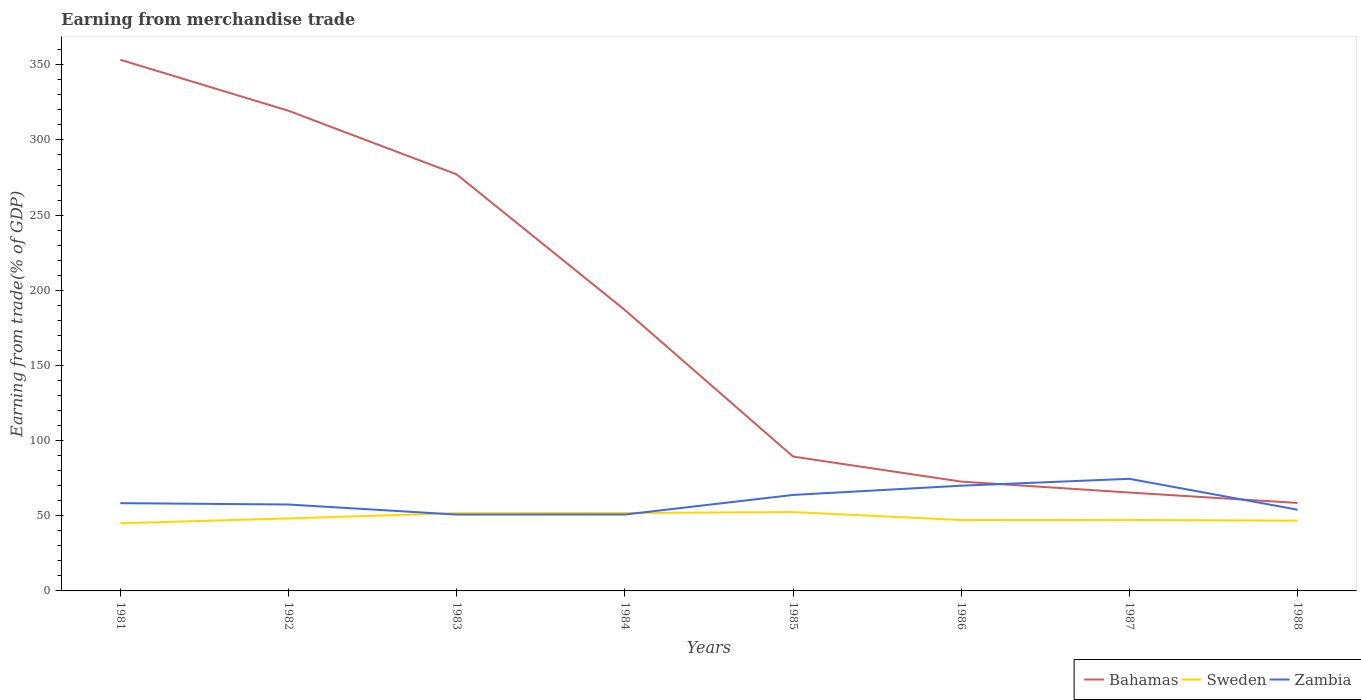Does the line corresponding to Zambia intersect with the line corresponding to Sweden?
Your answer should be very brief. Yes. Is the number of lines equal to the number of legend labels?
Make the answer very short. Yes. Across all years, what is the maximum earnings from trade in Zambia?
Provide a succinct answer. 50.8. In which year was the earnings from trade in Zambia maximum?
Provide a short and direct response. 1983. What is the total earnings from trade in Bahamas in the graph?
Provide a short and direct response. 253.96. What is the difference between the highest and the second highest earnings from trade in Sweden?
Keep it short and to the point. 7.48. How many lines are there?
Keep it short and to the point. 3. What is the difference between two consecutive major ticks on the Y-axis?
Make the answer very short. 50. Does the graph contain any zero values?
Offer a very short reply. No. What is the title of the graph?
Your answer should be very brief. Earning from merchandise trade. What is the label or title of the X-axis?
Provide a succinct answer. Years. What is the label or title of the Y-axis?
Your answer should be very brief. Earning from trade(% of GDP). What is the Earning from trade(% of GDP) of Bahamas in 1981?
Offer a very short reply. 353.31. What is the Earning from trade(% of GDP) of Sweden in 1981?
Offer a terse response. 44.97. What is the Earning from trade(% of GDP) in Zambia in 1981?
Offer a very short reply. 58.38. What is the Earning from trade(% of GDP) of Bahamas in 1982?
Offer a very short reply. 319.39. What is the Earning from trade(% of GDP) in Sweden in 1982?
Your answer should be compact. 48.23. What is the Earning from trade(% of GDP) in Zambia in 1982?
Make the answer very short. 57.48. What is the Earning from trade(% of GDP) of Bahamas in 1983?
Give a very brief answer. 277.07. What is the Earning from trade(% of GDP) of Sweden in 1983?
Offer a terse response. 51.72. What is the Earning from trade(% of GDP) in Zambia in 1983?
Provide a succinct answer. 50.8. What is the Earning from trade(% of GDP) of Bahamas in 1984?
Ensure brevity in your answer.  186.86. What is the Earning from trade(% of GDP) of Sweden in 1984?
Your answer should be compact. 51.83. What is the Earning from trade(% of GDP) in Zambia in 1984?
Offer a terse response. 50.82. What is the Earning from trade(% of GDP) of Bahamas in 1985?
Your answer should be very brief. 89.37. What is the Earning from trade(% of GDP) of Sweden in 1985?
Your response must be concise. 52.45. What is the Earning from trade(% of GDP) of Zambia in 1985?
Provide a short and direct response. 63.84. What is the Earning from trade(% of GDP) in Bahamas in 1986?
Your answer should be very brief. 72.72. What is the Earning from trade(% of GDP) of Sweden in 1986?
Offer a very short reply. 47.15. What is the Earning from trade(% of GDP) of Zambia in 1986?
Your answer should be compact. 69.99. What is the Earning from trade(% of GDP) in Bahamas in 1987?
Keep it short and to the point. 65.44. What is the Earning from trade(% of GDP) in Sweden in 1987?
Provide a short and direct response. 47.23. What is the Earning from trade(% of GDP) of Zambia in 1987?
Offer a very short reply. 74.56. What is the Earning from trade(% of GDP) of Bahamas in 1988?
Provide a short and direct response. 58.52. What is the Earning from trade(% of GDP) of Sweden in 1988?
Make the answer very short. 46.74. What is the Earning from trade(% of GDP) of Zambia in 1988?
Your answer should be very brief. 54.01. Across all years, what is the maximum Earning from trade(% of GDP) of Bahamas?
Your answer should be compact. 353.31. Across all years, what is the maximum Earning from trade(% of GDP) of Sweden?
Your answer should be very brief. 52.45. Across all years, what is the maximum Earning from trade(% of GDP) in Zambia?
Provide a succinct answer. 74.56. Across all years, what is the minimum Earning from trade(% of GDP) in Bahamas?
Make the answer very short. 58.52. Across all years, what is the minimum Earning from trade(% of GDP) in Sweden?
Provide a succinct answer. 44.97. Across all years, what is the minimum Earning from trade(% of GDP) of Zambia?
Provide a short and direct response. 50.8. What is the total Earning from trade(% of GDP) of Bahamas in the graph?
Offer a very short reply. 1422.68. What is the total Earning from trade(% of GDP) of Sweden in the graph?
Provide a succinct answer. 390.31. What is the total Earning from trade(% of GDP) of Zambia in the graph?
Provide a succinct answer. 479.88. What is the difference between the Earning from trade(% of GDP) of Bahamas in 1981 and that in 1982?
Provide a succinct answer. 33.92. What is the difference between the Earning from trade(% of GDP) of Sweden in 1981 and that in 1982?
Provide a short and direct response. -3.26. What is the difference between the Earning from trade(% of GDP) in Zambia in 1981 and that in 1982?
Your answer should be compact. 0.9. What is the difference between the Earning from trade(% of GDP) of Bahamas in 1981 and that in 1983?
Provide a succinct answer. 76.25. What is the difference between the Earning from trade(% of GDP) in Sweden in 1981 and that in 1983?
Offer a very short reply. -6.75. What is the difference between the Earning from trade(% of GDP) in Zambia in 1981 and that in 1983?
Your answer should be very brief. 7.58. What is the difference between the Earning from trade(% of GDP) in Bahamas in 1981 and that in 1984?
Offer a terse response. 166.45. What is the difference between the Earning from trade(% of GDP) in Sweden in 1981 and that in 1984?
Make the answer very short. -6.86. What is the difference between the Earning from trade(% of GDP) in Zambia in 1981 and that in 1984?
Ensure brevity in your answer.  7.56. What is the difference between the Earning from trade(% of GDP) in Bahamas in 1981 and that in 1985?
Ensure brevity in your answer.  263.94. What is the difference between the Earning from trade(% of GDP) in Sweden in 1981 and that in 1985?
Your response must be concise. -7.48. What is the difference between the Earning from trade(% of GDP) in Zambia in 1981 and that in 1985?
Ensure brevity in your answer.  -5.46. What is the difference between the Earning from trade(% of GDP) of Bahamas in 1981 and that in 1986?
Give a very brief answer. 280.59. What is the difference between the Earning from trade(% of GDP) of Sweden in 1981 and that in 1986?
Keep it short and to the point. -2.18. What is the difference between the Earning from trade(% of GDP) in Zambia in 1981 and that in 1986?
Offer a very short reply. -11.61. What is the difference between the Earning from trade(% of GDP) in Bahamas in 1981 and that in 1987?
Offer a very short reply. 287.87. What is the difference between the Earning from trade(% of GDP) in Sweden in 1981 and that in 1987?
Provide a short and direct response. -2.26. What is the difference between the Earning from trade(% of GDP) in Zambia in 1981 and that in 1987?
Make the answer very short. -16.18. What is the difference between the Earning from trade(% of GDP) in Bahamas in 1981 and that in 1988?
Keep it short and to the point. 294.79. What is the difference between the Earning from trade(% of GDP) in Sweden in 1981 and that in 1988?
Make the answer very short. -1.77. What is the difference between the Earning from trade(% of GDP) in Zambia in 1981 and that in 1988?
Your answer should be very brief. 4.37. What is the difference between the Earning from trade(% of GDP) of Bahamas in 1982 and that in 1983?
Ensure brevity in your answer.  42.33. What is the difference between the Earning from trade(% of GDP) of Sweden in 1982 and that in 1983?
Provide a succinct answer. -3.48. What is the difference between the Earning from trade(% of GDP) in Zambia in 1982 and that in 1983?
Your answer should be very brief. 6.68. What is the difference between the Earning from trade(% of GDP) in Bahamas in 1982 and that in 1984?
Offer a very short reply. 132.53. What is the difference between the Earning from trade(% of GDP) of Sweden in 1982 and that in 1984?
Make the answer very short. -3.6. What is the difference between the Earning from trade(% of GDP) in Zambia in 1982 and that in 1984?
Your answer should be very brief. 6.66. What is the difference between the Earning from trade(% of GDP) in Bahamas in 1982 and that in 1985?
Your answer should be compact. 230.02. What is the difference between the Earning from trade(% of GDP) of Sweden in 1982 and that in 1985?
Ensure brevity in your answer.  -4.21. What is the difference between the Earning from trade(% of GDP) of Zambia in 1982 and that in 1985?
Your answer should be compact. -6.36. What is the difference between the Earning from trade(% of GDP) in Bahamas in 1982 and that in 1986?
Give a very brief answer. 246.67. What is the difference between the Earning from trade(% of GDP) of Sweden in 1982 and that in 1986?
Your response must be concise. 1.09. What is the difference between the Earning from trade(% of GDP) of Zambia in 1982 and that in 1986?
Keep it short and to the point. -12.52. What is the difference between the Earning from trade(% of GDP) in Bahamas in 1982 and that in 1987?
Offer a very short reply. 253.96. What is the difference between the Earning from trade(% of GDP) in Sweden in 1982 and that in 1987?
Make the answer very short. 1.01. What is the difference between the Earning from trade(% of GDP) in Zambia in 1982 and that in 1987?
Give a very brief answer. -17.08. What is the difference between the Earning from trade(% of GDP) in Bahamas in 1982 and that in 1988?
Offer a terse response. 260.88. What is the difference between the Earning from trade(% of GDP) of Sweden in 1982 and that in 1988?
Your answer should be compact. 1.5. What is the difference between the Earning from trade(% of GDP) of Zambia in 1982 and that in 1988?
Offer a terse response. 3.47. What is the difference between the Earning from trade(% of GDP) in Bahamas in 1983 and that in 1984?
Your response must be concise. 90.21. What is the difference between the Earning from trade(% of GDP) of Sweden in 1983 and that in 1984?
Keep it short and to the point. -0.12. What is the difference between the Earning from trade(% of GDP) of Zambia in 1983 and that in 1984?
Give a very brief answer. -0.02. What is the difference between the Earning from trade(% of GDP) of Bahamas in 1983 and that in 1985?
Keep it short and to the point. 187.7. What is the difference between the Earning from trade(% of GDP) in Sweden in 1983 and that in 1985?
Keep it short and to the point. -0.73. What is the difference between the Earning from trade(% of GDP) of Zambia in 1983 and that in 1985?
Offer a very short reply. -13.04. What is the difference between the Earning from trade(% of GDP) of Bahamas in 1983 and that in 1986?
Ensure brevity in your answer.  204.35. What is the difference between the Earning from trade(% of GDP) of Sweden in 1983 and that in 1986?
Ensure brevity in your answer.  4.57. What is the difference between the Earning from trade(% of GDP) in Zambia in 1983 and that in 1986?
Make the answer very short. -19.2. What is the difference between the Earning from trade(% of GDP) in Bahamas in 1983 and that in 1987?
Offer a terse response. 211.63. What is the difference between the Earning from trade(% of GDP) in Sweden in 1983 and that in 1987?
Your response must be concise. 4.49. What is the difference between the Earning from trade(% of GDP) of Zambia in 1983 and that in 1987?
Make the answer very short. -23.76. What is the difference between the Earning from trade(% of GDP) in Bahamas in 1983 and that in 1988?
Your answer should be very brief. 218.55. What is the difference between the Earning from trade(% of GDP) in Sweden in 1983 and that in 1988?
Offer a terse response. 4.98. What is the difference between the Earning from trade(% of GDP) of Zambia in 1983 and that in 1988?
Provide a short and direct response. -3.21. What is the difference between the Earning from trade(% of GDP) of Bahamas in 1984 and that in 1985?
Your response must be concise. 97.49. What is the difference between the Earning from trade(% of GDP) in Sweden in 1984 and that in 1985?
Your response must be concise. -0.61. What is the difference between the Earning from trade(% of GDP) in Zambia in 1984 and that in 1985?
Keep it short and to the point. -13.02. What is the difference between the Earning from trade(% of GDP) of Bahamas in 1984 and that in 1986?
Ensure brevity in your answer.  114.14. What is the difference between the Earning from trade(% of GDP) in Sweden in 1984 and that in 1986?
Keep it short and to the point. 4.68. What is the difference between the Earning from trade(% of GDP) in Zambia in 1984 and that in 1986?
Offer a very short reply. -19.18. What is the difference between the Earning from trade(% of GDP) in Bahamas in 1984 and that in 1987?
Your answer should be very brief. 121.42. What is the difference between the Earning from trade(% of GDP) of Sweden in 1984 and that in 1987?
Make the answer very short. 4.61. What is the difference between the Earning from trade(% of GDP) in Zambia in 1984 and that in 1987?
Your answer should be very brief. -23.74. What is the difference between the Earning from trade(% of GDP) of Bahamas in 1984 and that in 1988?
Offer a very short reply. 128.34. What is the difference between the Earning from trade(% of GDP) of Sweden in 1984 and that in 1988?
Keep it short and to the point. 5.1. What is the difference between the Earning from trade(% of GDP) in Zambia in 1984 and that in 1988?
Keep it short and to the point. -3.19. What is the difference between the Earning from trade(% of GDP) of Bahamas in 1985 and that in 1986?
Your answer should be very brief. 16.65. What is the difference between the Earning from trade(% of GDP) in Sweden in 1985 and that in 1986?
Ensure brevity in your answer.  5.3. What is the difference between the Earning from trade(% of GDP) in Zambia in 1985 and that in 1986?
Give a very brief answer. -6.15. What is the difference between the Earning from trade(% of GDP) in Bahamas in 1985 and that in 1987?
Your answer should be very brief. 23.93. What is the difference between the Earning from trade(% of GDP) in Sweden in 1985 and that in 1987?
Provide a succinct answer. 5.22. What is the difference between the Earning from trade(% of GDP) of Zambia in 1985 and that in 1987?
Make the answer very short. -10.72. What is the difference between the Earning from trade(% of GDP) of Bahamas in 1985 and that in 1988?
Offer a very short reply. 30.85. What is the difference between the Earning from trade(% of GDP) of Sweden in 1985 and that in 1988?
Make the answer very short. 5.71. What is the difference between the Earning from trade(% of GDP) of Zambia in 1985 and that in 1988?
Offer a terse response. 9.83. What is the difference between the Earning from trade(% of GDP) in Bahamas in 1986 and that in 1987?
Your answer should be compact. 7.28. What is the difference between the Earning from trade(% of GDP) in Sweden in 1986 and that in 1987?
Your answer should be compact. -0.08. What is the difference between the Earning from trade(% of GDP) of Zambia in 1986 and that in 1987?
Give a very brief answer. -4.57. What is the difference between the Earning from trade(% of GDP) of Bahamas in 1986 and that in 1988?
Make the answer very short. 14.2. What is the difference between the Earning from trade(% of GDP) of Sweden in 1986 and that in 1988?
Make the answer very short. 0.41. What is the difference between the Earning from trade(% of GDP) of Zambia in 1986 and that in 1988?
Your answer should be compact. 15.98. What is the difference between the Earning from trade(% of GDP) of Bahamas in 1987 and that in 1988?
Make the answer very short. 6.92. What is the difference between the Earning from trade(% of GDP) of Sweden in 1987 and that in 1988?
Offer a terse response. 0.49. What is the difference between the Earning from trade(% of GDP) in Zambia in 1987 and that in 1988?
Keep it short and to the point. 20.55. What is the difference between the Earning from trade(% of GDP) in Bahamas in 1981 and the Earning from trade(% of GDP) in Sweden in 1982?
Give a very brief answer. 305.08. What is the difference between the Earning from trade(% of GDP) of Bahamas in 1981 and the Earning from trade(% of GDP) of Zambia in 1982?
Give a very brief answer. 295.84. What is the difference between the Earning from trade(% of GDP) in Sweden in 1981 and the Earning from trade(% of GDP) in Zambia in 1982?
Your response must be concise. -12.51. What is the difference between the Earning from trade(% of GDP) in Bahamas in 1981 and the Earning from trade(% of GDP) in Sweden in 1983?
Offer a very short reply. 301.6. What is the difference between the Earning from trade(% of GDP) in Bahamas in 1981 and the Earning from trade(% of GDP) in Zambia in 1983?
Keep it short and to the point. 302.52. What is the difference between the Earning from trade(% of GDP) of Sweden in 1981 and the Earning from trade(% of GDP) of Zambia in 1983?
Make the answer very short. -5.83. What is the difference between the Earning from trade(% of GDP) of Bahamas in 1981 and the Earning from trade(% of GDP) of Sweden in 1984?
Provide a short and direct response. 301.48. What is the difference between the Earning from trade(% of GDP) of Bahamas in 1981 and the Earning from trade(% of GDP) of Zambia in 1984?
Make the answer very short. 302.49. What is the difference between the Earning from trade(% of GDP) of Sweden in 1981 and the Earning from trade(% of GDP) of Zambia in 1984?
Provide a short and direct response. -5.85. What is the difference between the Earning from trade(% of GDP) in Bahamas in 1981 and the Earning from trade(% of GDP) in Sweden in 1985?
Offer a very short reply. 300.87. What is the difference between the Earning from trade(% of GDP) in Bahamas in 1981 and the Earning from trade(% of GDP) in Zambia in 1985?
Keep it short and to the point. 289.47. What is the difference between the Earning from trade(% of GDP) of Sweden in 1981 and the Earning from trade(% of GDP) of Zambia in 1985?
Ensure brevity in your answer.  -18.87. What is the difference between the Earning from trade(% of GDP) in Bahamas in 1981 and the Earning from trade(% of GDP) in Sweden in 1986?
Your answer should be compact. 306.16. What is the difference between the Earning from trade(% of GDP) in Bahamas in 1981 and the Earning from trade(% of GDP) in Zambia in 1986?
Make the answer very short. 283.32. What is the difference between the Earning from trade(% of GDP) in Sweden in 1981 and the Earning from trade(% of GDP) in Zambia in 1986?
Make the answer very short. -25.02. What is the difference between the Earning from trade(% of GDP) of Bahamas in 1981 and the Earning from trade(% of GDP) of Sweden in 1987?
Offer a terse response. 306.08. What is the difference between the Earning from trade(% of GDP) in Bahamas in 1981 and the Earning from trade(% of GDP) in Zambia in 1987?
Ensure brevity in your answer.  278.75. What is the difference between the Earning from trade(% of GDP) in Sweden in 1981 and the Earning from trade(% of GDP) in Zambia in 1987?
Your answer should be compact. -29.59. What is the difference between the Earning from trade(% of GDP) of Bahamas in 1981 and the Earning from trade(% of GDP) of Sweden in 1988?
Offer a very short reply. 306.58. What is the difference between the Earning from trade(% of GDP) in Bahamas in 1981 and the Earning from trade(% of GDP) in Zambia in 1988?
Keep it short and to the point. 299.3. What is the difference between the Earning from trade(% of GDP) of Sweden in 1981 and the Earning from trade(% of GDP) of Zambia in 1988?
Ensure brevity in your answer.  -9.04. What is the difference between the Earning from trade(% of GDP) in Bahamas in 1982 and the Earning from trade(% of GDP) in Sweden in 1983?
Ensure brevity in your answer.  267.68. What is the difference between the Earning from trade(% of GDP) in Bahamas in 1982 and the Earning from trade(% of GDP) in Zambia in 1983?
Provide a short and direct response. 268.6. What is the difference between the Earning from trade(% of GDP) in Sweden in 1982 and the Earning from trade(% of GDP) in Zambia in 1983?
Give a very brief answer. -2.56. What is the difference between the Earning from trade(% of GDP) of Bahamas in 1982 and the Earning from trade(% of GDP) of Sweden in 1984?
Offer a very short reply. 267.56. What is the difference between the Earning from trade(% of GDP) of Bahamas in 1982 and the Earning from trade(% of GDP) of Zambia in 1984?
Make the answer very short. 268.58. What is the difference between the Earning from trade(% of GDP) of Sweden in 1982 and the Earning from trade(% of GDP) of Zambia in 1984?
Your response must be concise. -2.58. What is the difference between the Earning from trade(% of GDP) of Bahamas in 1982 and the Earning from trade(% of GDP) of Sweden in 1985?
Offer a very short reply. 266.95. What is the difference between the Earning from trade(% of GDP) in Bahamas in 1982 and the Earning from trade(% of GDP) in Zambia in 1985?
Make the answer very short. 255.55. What is the difference between the Earning from trade(% of GDP) in Sweden in 1982 and the Earning from trade(% of GDP) in Zambia in 1985?
Offer a very short reply. -15.61. What is the difference between the Earning from trade(% of GDP) in Bahamas in 1982 and the Earning from trade(% of GDP) in Sweden in 1986?
Your answer should be very brief. 272.25. What is the difference between the Earning from trade(% of GDP) in Bahamas in 1982 and the Earning from trade(% of GDP) in Zambia in 1986?
Offer a terse response. 249.4. What is the difference between the Earning from trade(% of GDP) of Sweden in 1982 and the Earning from trade(% of GDP) of Zambia in 1986?
Provide a succinct answer. -21.76. What is the difference between the Earning from trade(% of GDP) in Bahamas in 1982 and the Earning from trade(% of GDP) in Sweden in 1987?
Your answer should be very brief. 272.17. What is the difference between the Earning from trade(% of GDP) in Bahamas in 1982 and the Earning from trade(% of GDP) in Zambia in 1987?
Ensure brevity in your answer.  244.83. What is the difference between the Earning from trade(% of GDP) in Sweden in 1982 and the Earning from trade(% of GDP) in Zambia in 1987?
Your answer should be very brief. -26.33. What is the difference between the Earning from trade(% of GDP) in Bahamas in 1982 and the Earning from trade(% of GDP) in Sweden in 1988?
Your answer should be very brief. 272.66. What is the difference between the Earning from trade(% of GDP) in Bahamas in 1982 and the Earning from trade(% of GDP) in Zambia in 1988?
Provide a succinct answer. 265.38. What is the difference between the Earning from trade(% of GDP) in Sweden in 1982 and the Earning from trade(% of GDP) in Zambia in 1988?
Give a very brief answer. -5.78. What is the difference between the Earning from trade(% of GDP) in Bahamas in 1983 and the Earning from trade(% of GDP) in Sweden in 1984?
Your response must be concise. 225.23. What is the difference between the Earning from trade(% of GDP) of Bahamas in 1983 and the Earning from trade(% of GDP) of Zambia in 1984?
Your answer should be very brief. 226.25. What is the difference between the Earning from trade(% of GDP) in Sweden in 1983 and the Earning from trade(% of GDP) in Zambia in 1984?
Offer a terse response. 0.9. What is the difference between the Earning from trade(% of GDP) of Bahamas in 1983 and the Earning from trade(% of GDP) of Sweden in 1985?
Provide a short and direct response. 224.62. What is the difference between the Earning from trade(% of GDP) of Bahamas in 1983 and the Earning from trade(% of GDP) of Zambia in 1985?
Give a very brief answer. 213.22. What is the difference between the Earning from trade(% of GDP) of Sweden in 1983 and the Earning from trade(% of GDP) of Zambia in 1985?
Offer a very short reply. -12.12. What is the difference between the Earning from trade(% of GDP) of Bahamas in 1983 and the Earning from trade(% of GDP) of Sweden in 1986?
Offer a very short reply. 229.92. What is the difference between the Earning from trade(% of GDP) of Bahamas in 1983 and the Earning from trade(% of GDP) of Zambia in 1986?
Ensure brevity in your answer.  207.07. What is the difference between the Earning from trade(% of GDP) of Sweden in 1983 and the Earning from trade(% of GDP) of Zambia in 1986?
Ensure brevity in your answer.  -18.28. What is the difference between the Earning from trade(% of GDP) of Bahamas in 1983 and the Earning from trade(% of GDP) of Sweden in 1987?
Ensure brevity in your answer.  229.84. What is the difference between the Earning from trade(% of GDP) of Bahamas in 1983 and the Earning from trade(% of GDP) of Zambia in 1987?
Give a very brief answer. 202.5. What is the difference between the Earning from trade(% of GDP) of Sweden in 1983 and the Earning from trade(% of GDP) of Zambia in 1987?
Provide a short and direct response. -22.84. What is the difference between the Earning from trade(% of GDP) in Bahamas in 1983 and the Earning from trade(% of GDP) in Sweden in 1988?
Provide a succinct answer. 230.33. What is the difference between the Earning from trade(% of GDP) in Bahamas in 1983 and the Earning from trade(% of GDP) in Zambia in 1988?
Provide a short and direct response. 223.06. What is the difference between the Earning from trade(% of GDP) in Sweden in 1983 and the Earning from trade(% of GDP) in Zambia in 1988?
Ensure brevity in your answer.  -2.29. What is the difference between the Earning from trade(% of GDP) of Bahamas in 1984 and the Earning from trade(% of GDP) of Sweden in 1985?
Keep it short and to the point. 134.41. What is the difference between the Earning from trade(% of GDP) in Bahamas in 1984 and the Earning from trade(% of GDP) in Zambia in 1985?
Your answer should be very brief. 123.02. What is the difference between the Earning from trade(% of GDP) in Sweden in 1984 and the Earning from trade(% of GDP) in Zambia in 1985?
Your answer should be very brief. -12.01. What is the difference between the Earning from trade(% of GDP) of Bahamas in 1984 and the Earning from trade(% of GDP) of Sweden in 1986?
Your response must be concise. 139.71. What is the difference between the Earning from trade(% of GDP) of Bahamas in 1984 and the Earning from trade(% of GDP) of Zambia in 1986?
Give a very brief answer. 116.87. What is the difference between the Earning from trade(% of GDP) of Sweden in 1984 and the Earning from trade(% of GDP) of Zambia in 1986?
Your answer should be compact. -18.16. What is the difference between the Earning from trade(% of GDP) of Bahamas in 1984 and the Earning from trade(% of GDP) of Sweden in 1987?
Offer a very short reply. 139.63. What is the difference between the Earning from trade(% of GDP) in Bahamas in 1984 and the Earning from trade(% of GDP) in Zambia in 1987?
Offer a terse response. 112.3. What is the difference between the Earning from trade(% of GDP) of Sweden in 1984 and the Earning from trade(% of GDP) of Zambia in 1987?
Your response must be concise. -22.73. What is the difference between the Earning from trade(% of GDP) of Bahamas in 1984 and the Earning from trade(% of GDP) of Sweden in 1988?
Provide a short and direct response. 140.12. What is the difference between the Earning from trade(% of GDP) of Bahamas in 1984 and the Earning from trade(% of GDP) of Zambia in 1988?
Provide a succinct answer. 132.85. What is the difference between the Earning from trade(% of GDP) in Sweden in 1984 and the Earning from trade(% of GDP) in Zambia in 1988?
Give a very brief answer. -2.18. What is the difference between the Earning from trade(% of GDP) of Bahamas in 1985 and the Earning from trade(% of GDP) of Sweden in 1986?
Keep it short and to the point. 42.22. What is the difference between the Earning from trade(% of GDP) of Bahamas in 1985 and the Earning from trade(% of GDP) of Zambia in 1986?
Keep it short and to the point. 19.38. What is the difference between the Earning from trade(% of GDP) of Sweden in 1985 and the Earning from trade(% of GDP) of Zambia in 1986?
Offer a terse response. -17.55. What is the difference between the Earning from trade(% of GDP) in Bahamas in 1985 and the Earning from trade(% of GDP) in Sweden in 1987?
Offer a terse response. 42.14. What is the difference between the Earning from trade(% of GDP) of Bahamas in 1985 and the Earning from trade(% of GDP) of Zambia in 1987?
Your answer should be compact. 14.81. What is the difference between the Earning from trade(% of GDP) in Sweden in 1985 and the Earning from trade(% of GDP) in Zambia in 1987?
Make the answer very short. -22.12. What is the difference between the Earning from trade(% of GDP) in Bahamas in 1985 and the Earning from trade(% of GDP) in Sweden in 1988?
Make the answer very short. 42.63. What is the difference between the Earning from trade(% of GDP) in Bahamas in 1985 and the Earning from trade(% of GDP) in Zambia in 1988?
Offer a terse response. 35.36. What is the difference between the Earning from trade(% of GDP) in Sweden in 1985 and the Earning from trade(% of GDP) in Zambia in 1988?
Offer a terse response. -1.57. What is the difference between the Earning from trade(% of GDP) in Bahamas in 1986 and the Earning from trade(% of GDP) in Sweden in 1987?
Ensure brevity in your answer.  25.49. What is the difference between the Earning from trade(% of GDP) in Bahamas in 1986 and the Earning from trade(% of GDP) in Zambia in 1987?
Offer a terse response. -1.84. What is the difference between the Earning from trade(% of GDP) of Sweden in 1986 and the Earning from trade(% of GDP) of Zambia in 1987?
Offer a terse response. -27.41. What is the difference between the Earning from trade(% of GDP) of Bahamas in 1986 and the Earning from trade(% of GDP) of Sweden in 1988?
Keep it short and to the point. 25.98. What is the difference between the Earning from trade(% of GDP) in Bahamas in 1986 and the Earning from trade(% of GDP) in Zambia in 1988?
Give a very brief answer. 18.71. What is the difference between the Earning from trade(% of GDP) of Sweden in 1986 and the Earning from trade(% of GDP) of Zambia in 1988?
Provide a succinct answer. -6.86. What is the difference between the Earning from trade(% of GDP) of Bahamas in 1987 and the Earning from trade(% of GDP) of Sweden in 1988?
Provide a short and direct response. 18.7. What is the difference between the Earning from trade(% of GDP) of Bahamas in 1987 and the Earning from trade(% of GDP) of Zambia in 1988?
Your response must be concise. 11.43. What is the difference between the Earning from trade(% of GDP) of Sweden in 1987 and the Earning from trade(% of GDP) of Zambia in 1988?
Offer a very short reply. -6.78. What is the average Earning from trade(% of GDP) of Bahamas per year?
Offer a very short reply. 177.83. What is the average Earning from trade(% of GDP) in Sweden per year?
Keep it short and to the point. 48.79. What is the average Earning from trade(% of GDP) of Zambia per year?
Your answer should be compact. 59.99. In the year 1981, what is the difference between the Earning from trade(% of GDP) of Bahamas and Earning from trade(% of GDP) of Sweden?
Your answer should be very brief. 308.34. In the year 1981, what is the difference between the Earning from trade(% of GDP) in Bahamas and Earning from trade(% of GDP) in Zambia?
Your response must be concise. 294.93. In the year 1981, what is the difference between the Earning from trade(% of GDP) in Sweden and Earning from trade(% of GDP) in Zambia?
Your answer should be compact. -13.41. In the year 1982, what is the difference between the Earning from trade(% of GDP) in Bahamas and Earning from trade(% of GDP) in Sweden?
Offer a terse response. 271.16. In the year 1982, what is the difference between the Earning from trade(% of GDP) in Bahamas and Earning from trade(% of GDP) in Zambia?
Provide a short and direct response. 261.92. In the year 1982, what is the difference between the Earning from trade(% of GDP) in Sweden and Earning from trade(% of GDP) in Zambia?
Your answer should be very brief. -9.24. In the year 1983, what is the difference between the Earning from trade(% of GDP) in Bahamas and Earning from trade(% of GDP) in Sweden?
Keep it short and to the point. 225.35. In the year 1983, what is the difference between the Earning from trade(% of GDP) of Bahamas and Earning from trade(% of GDP) of Zambia?
Provide a short and direct response. 226.27. In the year 1983, what is the difference between the Earning from trade(% of GDP) of Sweden and Earning from trade(% of GDP) of Zambia?
Keep it short and to the point. 0.92. In the year 1984, what is the difference between the Earning from trade(% of GDP) in Bahamas and Earning from trade(% of GDP) in Sweden?
Provide a succinct answer. 135.03. In the year 1984, what is the difference between the Earning from trade(% of GDP) in Bahamas and Earning from trade(% of GDP) in Zambia?
Provide a short and direct response. 136.04. In the year 1984, what is the difference between the Earning from trade(% of GDP) of Sweden and Earning from trade(% of GDP) of Zambia?
Provide a succinct answer. 1.01. In the year 1985, what is the difference between the Earning from trade(% of GDP) in Bahamas and Earning from trade(% of GDP) in Sweden?
Provide a short and direct response. 36.92. In the year 1985, what is the difference between the Earning from trade(% of GDP) in Bahamas and Earning from trade(% of GDP) in Zambia?
Your response must be concise. 25.53. In the year 1985, what is the difference between the Earning from trade(% of GDP) in Sweden and Earning from trade(% of GDP) in Zambia?
Provide a short and direct response. -11.4. In the year 1986, what is the difference between the Earning from trade(% of GDP) of Bahamas and Earning from trade(% of GDP) of Sweden?
Make the answer very short. 25.57. In the year 1986, what is the difference between the Earning from trade(% of GDP) in Bahamas and Earning from trade(% of GDP) in Zambia?
Offer a terse response. 2.73. In the year 1986, what is the difference between the Earning from trade(% of GDP) of Sweden and Earning from trade(% of GDP) of Zambia?
Provide a short and direct response. -22.85. In the year 1987, what is the difference between the Earning from trade(% of GDP) of Bahamas and Earning from trade(% of GDP) of Sweden?
Your answer should be compact. 18.21. In the year 1987, what is the difference between the Earning from trade(% of GDP) in Bahamas and Earning from trade(% of GDP) in Zambia?
Give a very brief answer. -9.12. In the year 1987, what is the difference between the Earning from trade(% of GDP) in Sweden and Earning from trade(% of GDP) in Zambia?
Your answer should be compact. -27.33. In the year 1988, what is the difference between the Earning from trade(% of GDP) in Bahamas and Earning from trade(% of GDP) in Sweden?
Make the answer very short. 11.78. In the year 1988, what is the difference between the Earning from trade(% of GDP) of Bahamas and Earning from trade(% of GDP) of Zambia?
Your answer should be very brief. 4.51. In the year 1988, what is the difference between the Earning from trade(% of GDP) of Sweden and Earning from trade(% of GDP) of Zambia?
Give a very brief answer. -7.27. What is the ratio of the Earning from trade(% of GDP) in Bahamas in 1981 to that in 1982?
Give a very brief answer. 1.11. What is the ratio of the Earning from trade(% of GDP) of Sweden in 1981 to that in 1982?
Make the answer very short. 0.93. What is the ratio of the Earning from trade(% of GDP) of Zambia in 1981 to that in 1982?
Make the answer very short. 1.02. What is the ratio of the Earning from trade(% of GDP) in Bahamas in 1981 to that in 1983?
Offer a terse response. 1.28. What is the ratio of the Earning from trade(% of GDP) in Sweden in 1981 to that in 1983?
Offer a very short reply. 0.87. What is the ratio of the Earning from trade(% of GDP) in Zambia in 1981 to that in 1983?
Offer a terse response. 1.15. What is the ratio of the Earning from trade(% of GDP) of Bahamas in 1981 to that in 1984?
Your answer should be compact. 1.89. What is the ratio of the Earning from trade(% of GDP) of Sweden in 1981 to that in 1984?
Provide a short and direct response. 0.87. What is the ratio of the Earning from trade(% of GDP) of Zambia in 1981 to that in 1984?
Your response must be concise. 1.15. What is the ratio of the Earning from trade(% of GDP) of Bahamas in 1981 to that in 1985?
Your answer should be very brief. 3.95. What is the ratio of the Earning from trade(% of GDP) of Sweden in 1981 to that in 1985?
Make the answer very short. 0.86. What is the ratio of the Earning from trade(% of GDP) in Zambia in 1981 to that in 1985?
Provide a succinct answer. 0.91. What is the ratio of the Earning from trade(% of GDP) of Bahamas in 1981 to that in 1986?
Your response must be concise. 4.86. What is the ratio of the Earning from trade(% of GDP) of Sweden in 1981 to that in 1986?
Ensure brevity in your answer.  0.95. What is the ratio of the Earning from trade(% of GDP) of Zambia in 1981 to that in 1986?
Your answer should be compact. 0.83. What is the ratio of the Earning from trade(% of GDP) in Bahamas in 1981 to that in 1987?
Make the answer very short. 5.4. What is the ratio of the Earning from trade(% of GDP) in Sweden in 1981 to that in 1987?
Offer a very short reply. 0.95. What is the ratio of the Earning from trade(% of GDP) of Zambia in 1981 to that in 1987?
Keep it short and to the point. 0.78. What is the ratio of the Earning from trade(% of GDP) in Bahamas in 1981 to that in 1988?
Provide a short and direct response. 6.04. What is the ratio of the Earning from trade(% of GDP) of Sweden in 1981 to that in 1988?
Offer a terse response. 0.96. What is the ratio of the Earning from trade(% of GDP) in Zambia in 1981 to that in 1988?
Keep it short and to the point. 1.08. What is the ratio of the Earning from trade(% of GDP) in Bahamas in 1982 to that in 1983?
Offer a terse response. 1.15. What is the ratio of the Earning from trade(% of GDP) in Sweden in 1982 to that in 1983?
Keep it short and to the point. 0.93. What is the ratio of the Earning from trade(% of GDP) of Zambia in 1982 to that in 1983?
Ensure brevity in your answer.  1.13. What is the ratio of the Earning from trade(% of GDP) of Bahamas in 1982 to that in 1984?
Make the answer very short. 1.71. What is the ratio of the Earning from trade(% of GDP) in Sweden in 1982 to that in 1984?
Give a very brief answer. 0.93. What is the ratio of the Earning from trade(% of GDP) of Zambia in 1982 to that in 1984?
Keep it short and to the point. 1.13. What is the ratio of the Earning from trade(% of GDP) in Bahamas in 1982 to that in 1985?
Give a very brief answer. 3.57. What is the ratio of the Earning from trade(% of GDP) of Sweden in 1982 to that in 1985?
Give a very brief answer. 0.92. What is the ratio of the Earning from trade(% of GDP) of Zambia in 1982 to that in 1985?
Offer a very short reply. 0.9. What is the ratio of the Earning from trade(% of GDP) of Bahamas in 1982 to that in 1986?
Make the answer very short. 4.39. What is the ratio of the Earning from trade(% of GDP) in Sweden in 1982 to that in 1986?
Give a very brief answer. 1.02. What is the ratio of the Earning from trade(% of GDP) of Zambia in 1982 to that in 1986?
Make the answer very short. 0.82. What is the ratio of the Earning from trade(% of GDP) of Bahamas in 1982 to that in 1987?
Ensure brevity in your answer.  4.88. What is the ratio of the Earning from trade(% of GDP) in Sweden in 1982 to that in 1987?
Provide a succinct answer. 1.02. What is the ratio of the Earning from trade(% of GDP) in Zambia in 1982 to that in 1987?
Your answer should be compact. 0.77. What is the ratio of the Earning from trade(% of GDP) of Bahamas in 1982 to that in 1988?
Provide a succinct answer. 5.46. What is the ratio of the Earning from trade(% of GDP) in Sweden in 1982 to that in 1988?
Provide a succinct answer. 1.03. What is the ratio of the Earning from trade(% of GDP) of Zambia in 1982 to that in 1988?
Your answer should be very brief. 1.06. What is the ratio of the Earning from trade(% of GDP) in Bahamas in 1983 to that in 1984?
Your response must be concise. 1.48. What is the ratio of the Earning from trade(% of GDP) in Zambia in 1983 to that in 1984?
Keep it short and to the point. 1. What is the ratio of the Earning from trade(% of GDP) in Bahamas in 1983 to that in 1985?
Offer a very short reply. 3.1. What is the ratio of the Earning from trade(% of GDP) of Sweden in 1983 to that in 1985?
Make the answer very short. 0.99. What is the ratio of the Earning from trade(% of GDP) of Zambia in 1983 to that in 1985?
Keep it short and to the point. 0.8. What is the ratio of the Earning from trade(% of GDP) of Bahamas in 1983 to that in 1986?
Ensure brevity in your answer.  3.81. What is the ratio of the Earning from trade(% of GDP) of Sweden in 1983 to that in 1986?
Your answer should be very brief. 1.1. What is the ratio of the Earning from trade(% of GDP) in Zambia in 1983 to that in 1986?
Offer a terse response. 0.73. What is the ratio of the Earning from trade(% of GDP) of Bahamas in 1983 to that in 1987?
Your answer should be very brief. 4.23. What is the ratio of the Earning from trade(% of GDP) in Sweden in 1983 to that in 1987?
Ensure brevity in your answer.  1.1. What is the ratio of the Earning from trade(% of GDP) of Zambia in 1983 to that in 1987?
Offer a very short reply. 0.68. What is the ratio of the Earning from trade(% of GDP) of Bahamas in 1983 to that in 1988?
Provide a succinct answer. 4.73. What is the ratio of the Earning from trade(% of GDP) of Sweden in 1983 to that in 1988?
Offer a very short reply. 1.11. What is the ratio of the Earning from trade(% of GDP) of Zambia in 1983 to that in 1988?
Your answer should be very brief. 0.94. What is the ratio of the Earning from trade(% of GDP) of Bahamas in 1984 to that in 1985?
Ensure brevity in your answer.  2.09. What is the ratio of the Earning from trade(% of GDP) of Sweden in 1984 to that in 1985?
Make the answer very short. 0.99. What is the ratio of the Earning from trade(% of GDP) of Zambia in 1984 to that in 1985?
Offer a very short reply. 0.8. What is the ratio of the Earning from trade(% of GDP) of Bahamas in 1984 to that in 1986?
Keep it short and to the point. 2.57. What is the ratio of the Earning from trade(% of GDP) in Sweden in 1984 to that in 1986?
Your response must be concise. 1.1. What is the ratio of the Earning from trade(% of GDP) in Zambia in 1984 to that in 1986?
Make the answer very short. 0.73. What is the ratio of the Earning from trade(% of GDP) of Bahamas in 1984 to that in 1987?
Ensure brevity in your answer.  2.86. What is the ratio of the Earning from trade(% of GDP) in Sweden in 1984 to that in 1987?
Ensure brevity in your answer.  1.1. What is the ratio of the Earning from trade(% of GDP) in Zambia in 1984 to that in 1987?
Provide a short and direct response. 0.68. What is the ratio of the Earning from trade(% of GDP) in Bahamas in 1984 to that in 1988?
Keep it short and to the point. 3.19. What is the ratio of the Earning from trade(% of GDP) in Sweden in 1984 to that in 1988?
Make the answer very short. 1.11. What is the ratio of the Earning from trade(% of GDP) in Zambia in 1984 to that in 1988?
Give a very brief answer. 0.94. What is the ratio of the Earning from trade(% of GDP) of Bahamas in 1985 to that in 1986?
Give a very brief answer. 1.23. What is the ratio of the Earning from trade(% of GDP) of Sweden in 1985 to that in 1986?
Make the answer very short. 1.11. What is the ratio of the Earning from trade(% of GDP) of Zambia in 1985 to that in 1986?
Make the answer very short. 0.91. What is the ratio of the Earning from trade(% of GDP) in Bahamas in 1985 to that in 1987?
Your answer should be compact. 1.37. What is the ratio of the Earning from trade(% of GDP) of Sweden in 1985 to that in 1987?
Make the answer very short. 1.11. What is the ratio of the Earning from trade(% of GDP) in Zambia in 1985 to that in 1987?
Your answer should be compact. 0.86. What is the ratio of the Earning from trade(% of GDP) in Bahamas in 1985 to that in 1988?
Ensure brevity in your answer.  1.53. What is the ratio of the Earning from trade(% of GDP) of Sweden in 1985 to that in 1988?
Offer a terse response. 1.12. What is the ratio of the Earning from trade(% of GDP) of Zambia in 1985 to that in 1988?
Ensure brevity in your answer.  1.18. What is the ratio of the Earning from trade(% of GDP) in Bahamas in 1986 to that in 1987?
Your answer should be very brief. 1.11. What is the ratio of the Earning from trade(% of GDP) of Zambia in 1986 to that in 1987?
Provide a short and direct response. 0.94. What is the ratio of the Earning from trade(% of GDP) of Bahamas in 1986 to that in 1988?
Offer a terse response. 1.24. What is the ratio of the Earning from trade(% of GDP) in Sweden in 1986 to that in 1988?
Your response must be concise. 1.01. What is the ratio of the Earning from trade(% of GDP) in Zambia in 1986 to that in 1988?
Ensure brevity in your answer.  1.3. What is the ratio of the Earning from trade(% of GDP) in Bahamas in 1987 to that in 1988?
Give a very brief answer. 1.12. What is the ratio of the Earning from trade(% of GDP) of Sweden in 1987 to that in 1988?
Provide a short and direct response. 1.01. What is the ratio of the Earning from trade(% of GDP) of Zambia in 1987 to that in 1988?
Give a very brief answer. 1.38. What is the difference between the highest and the second highest Earning from trade(% of GDP) in Bahamas?
Offer a terse response. 33.92. What is the difference between the highest and the second highest Earning from trade(% of GDP) in Sweden?
Provide a short and direct response. 0.61. What is the difference between the highest and the second highest Earning from trade(% of GDP) in Zambia?
Give a very brief answer. 4.57. What is the difference between the highest and the lowest Earning from trade(% of GDP) in Bahamas?
Offer a very short reply. 294.79. What is the difference between the highest and the lowest Earning from trade(% of GDP) of Sweden?
Give a very brief answer. 7.48. What is the difference between the highest and the lowest Earning from trade(% of GDP) in Zambia?
Give a very brief answer. 23.76. 